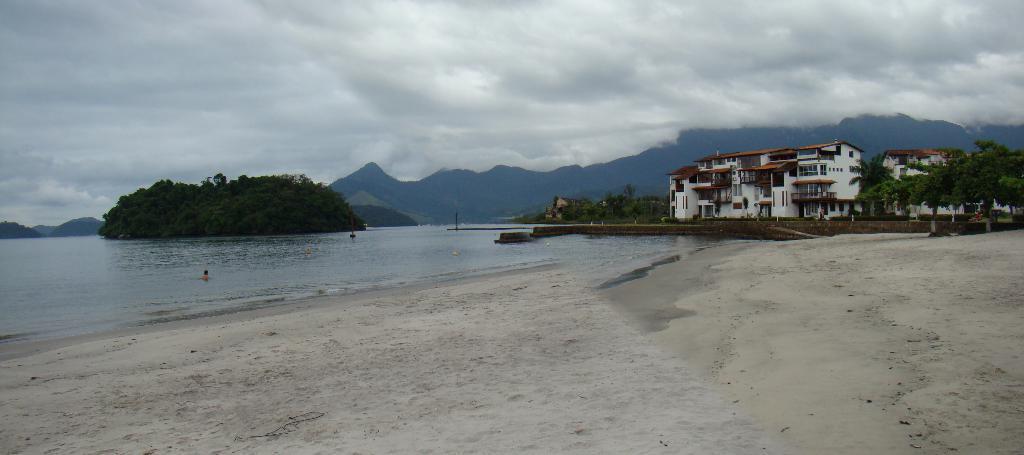How would you summarize this image in a sentence or two? In this image in front there is sand. In the center of the image there are people swimming in the water. There are trees. On the right side of the image there are buildings, trees. In the background of the image there are mountains and sky. 